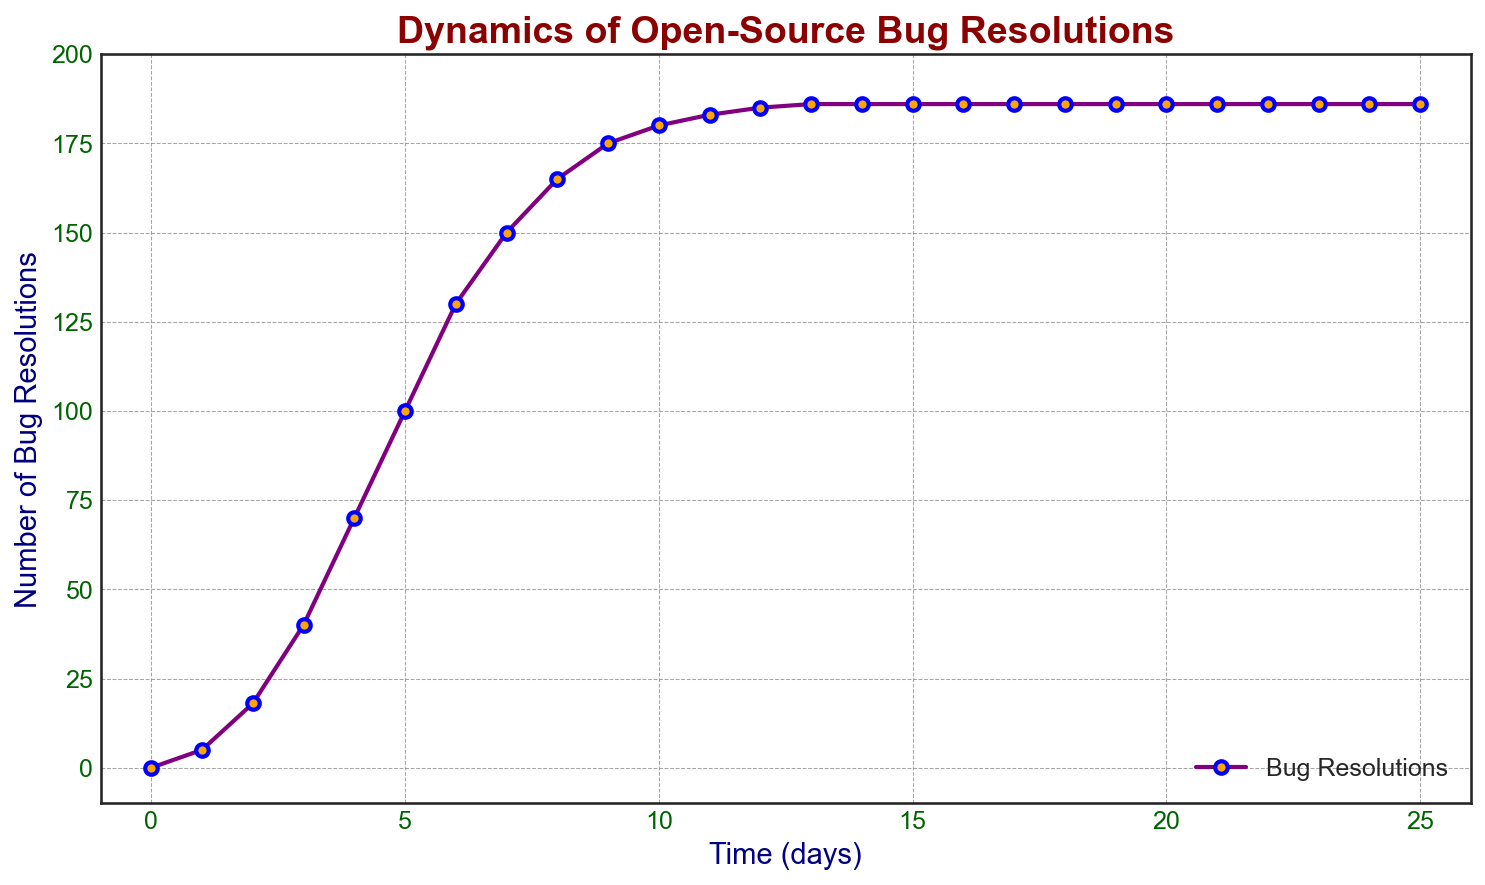What is the maximum number of bug resolutions reached over time? By observing the figure, the highest point on the vertical axis "Number of Bug Resolutions" indicates the maximum number of resolutions achieved. The graph shows this maximum at the 186 mark, which is sustained from day 14 onwards.
Answer: 186 How many days did it take to resolve 100 bugs? The graph can be interpolated to find the closest day when the bug resolutions reached 100. The plotted points indicate that on day 5, the number of bug resolutions hits 100.
Answer: 5 Between days 4 and 6, how many bugs were resolved? From the graph, the number of bug resolutions at day 4 is 70 and at day 6 is 130. The difference between the two values will give the number of bugs resolved in that time frame: 130 - 70 = 60.
Answer: 60 Is the rate of bug resolutions faster in the first 3 days or the last 3 days? The rate of bug resolutions can be calculated by checking the change in resolutions over the given time periods. For the first 3 days: from 0 to 40 (40/3 = 13.33 bugs/day). For the last 3 days: from 186 to 186 (0/3 = 0 bugs/day). Thus, the rate is faster in the first 3 days.
Answer: First 3 days What is the average number of bug resolutions over the first 10 days? The number of bug resolutions at each day is given. Sum these values from day 0 to day 10 and divide by the number of days (11). (0 + 5 + 18 + 40 + 70 + 100 + 130 + 150 + 165 + 175 + 180) / 11 = 103.91.
Answer: 103.91 What color is used for the line plot and the markers in the figure? Based on the description provided, the line plot is colored purple, and the markers are orange with blue edges.
Answer: Purple line, orange markers, blue edges How many days after day 7 did the bug resolution count become constant? The figure shows the bug resolutions reach 186 and remain constant from day 14 onwards. Therefore, 14 - 7 = 7 days after day 7.
Answer: 7 During which interval did the number of bug resolutions increase the most rapidly? Looking at the steepness of the graph, the interval from day 3 to day 5 shows the most rapid increase where the resolutions jump from 40 to 100.
Answer: Day 3 to Day 5 